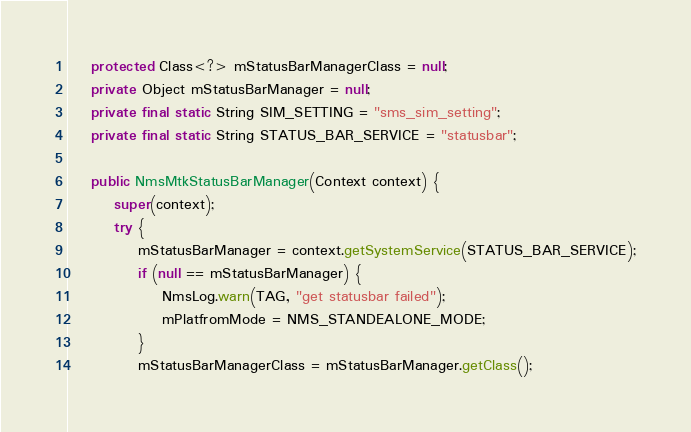<code> <loc_0><loc_0><loc_500><loc_500><_Java_>    protected Class<?> mStatusBarManagerClass = null;
    private Object mStatusBarManager = null;
    private final static String SIM_SETTING = "sms_sim_setting";
    private final static String STATUS_BAR_SERVICE = "statusbar";

    public NmsMtkStatusBarManager(Context context) {
        super(context);
        try {
            mStatusBarManager = context.getSystemService(STATUS_BAR_SERVICE);
            if (null == mStatusBarManager) {
                NmsLog.warn(TAG, "get statusbar failed");
                mPlatfromMode = NMS_STANDEALONE_MODE;
            }
            mStatusBarManagerClass = mStatusBarManager.getClass();</code> 